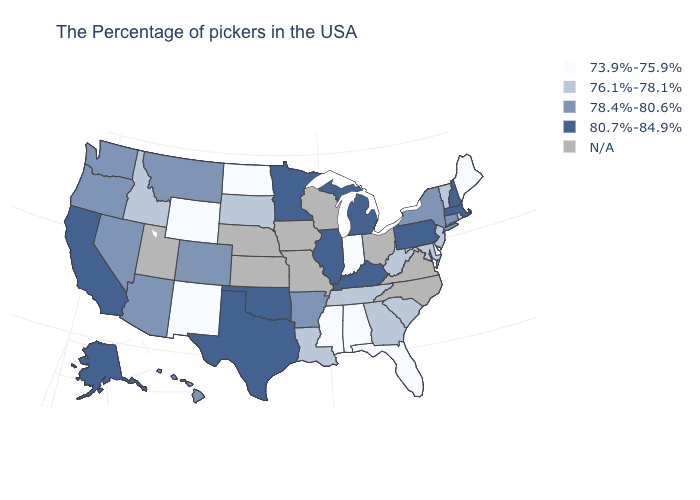Name the states that have a value in the range N/A?
Write a very short answer. Virginia, North Carolina, Ohio, Wisconsin, Missouri, Iowa, Kansas, Nebraska, Utah. How many symbols are there in the legend?
Answer briefly. 5. Is the legend a continuous bar?
Be succinct. No. What is the highest value in the MidWest ?
Write a very short answer. 80.7%-84.9%. Name the states that have a value in the range 78.4%-80.6%?
Be succinct. Connecticut, New York, Arkansas, Colorado, Montana, Arizona, Nevada, Washington, Oregon, Hawaii. Does Oklahoma have the highest value in the USA?
Give a very brief answer. Yes. Does California have the highest value in the USA?
Keep it brief. Yes. Name the states that have a value in the range 76.1%-78.1%?
Give a very brief answer. Rhode Island, Vermont, New Jersey, Maryland, South Carolina, West Virginia, Georgia, Tennessee, Louisiana, South Dakota, Idaho. What is the lowest value in states that border Kansas?
Give a very brief answer. 78.4%-80.6%. What is the value of Tennessee?
Short answer required. 76.1%-78.1%. What is the lowest value in the USA?
Be succinct. 73.9%-75.9%. Which states have the lowest value in the USA?
Quick response, please. Maine, Delaware, Florida, Indiana, Alabama, Mississippi, North Dakota, Wyoming, New Mexico. Does Texas have the highest value in the USA?
Answer briefly. Yes. What is the lowest value in the MidWest?
Write a very short answer. 73.9%-75.9%. What is the value of Florida?
Be succinct. 73.9%-75.9%. 